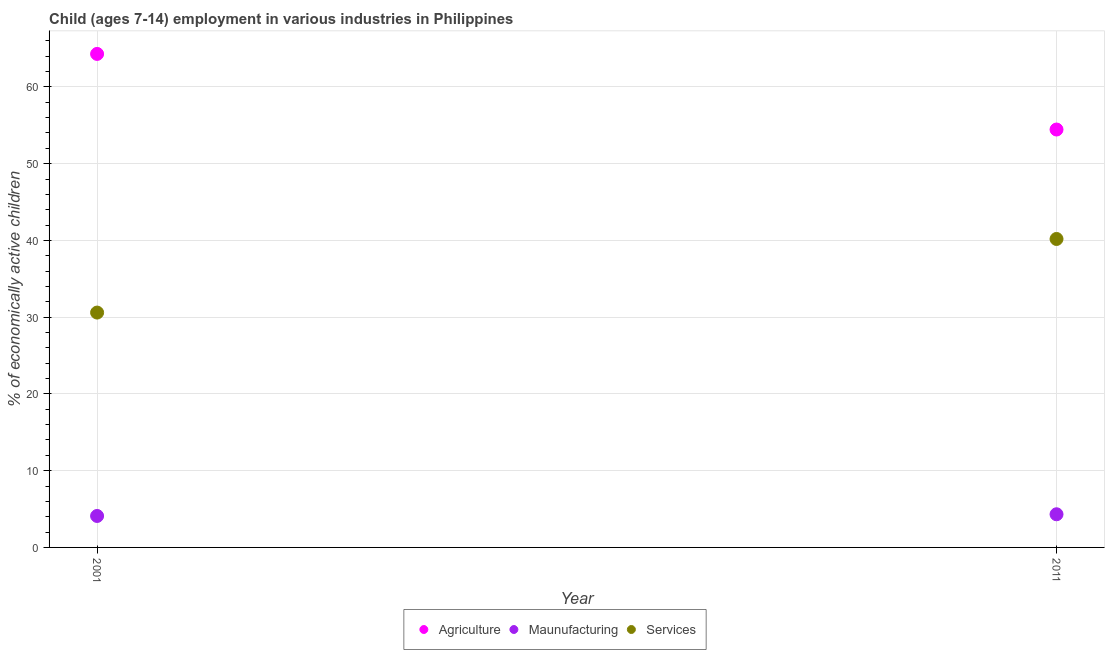How many different coloured dotlines are there?
Your answer should be very brief. 3. Is the number of dotlines equal to the number of legend labels?
Make the answer very short. Yes. What is the percentage of economically active children in manufacturing in 2011?
Offer a very short reply. 4.32. Across all years, what is the maximum percentage of economically active children in services?
Your answer should be compact. 40.19. Across all years, what is the minimum percentage of economically active children in agriculture?
Make the answer very short. 54.45. In which year was the percentage of economically active children in manufacturing maximum?
Give a very brief answer. 2011. What is the total percentage of economically active children in manufacturing in the graph?
Offer a very short reply. 8.42. What is the difference between the percentage of economically active children in agriculture in 2001 and that in 2011?
Give a very brief answer. 9.85. What is the difference between the percentage of economically active children in services in 2011 and the percentage of economically active children in manufacturing in 2001?
Your response must be concise. 36.09. What is the average percentage of economically active children in manufacturing per year?
Keep it short and to the point. 4.21. In the year 2001, what is the difference between the percentage of economically active children in manufacturing and percentage of economically active children in services?
Your answer should be compact. -26.5. What is the ratio of the percentage of economically active children in manufacturing in 2001 to that in 2011?
Your answer should be very brief. 0.95. Is the percentage of economically active children in agriculture in 2001 less than that in 2011?
Ensure brevity in your answer.  No. Is the percentage of economically active children in manufacturing strictly less than the percentage of economically active children in agriculture over the years?
Make the answer very short. Yes. What is the difference between two consecutive major ticks on the Y-axis?
Provide a short and direct response. 10. Does the graph contain grids?
Make the answer very short. Yes. How many legend labels are there?
Your response must be concise. 3. How are the legend labels stacked?
Make the answer very short. Horizontal. What is the title of the graph?
Give a very brief answer. Child (ages 7-14) employment in various industries in Philippines. What is the label or title of the X-axis?
Ensure brevity in your answer.  Year. What is the label or title of the Y-axis?
Ensure brevity in your answer.  % of economically active children. What is the % of economically active children in Agriculture in 2001?
Offer a terse response. 64.3. What is the % of economically active children in Maunufacturing in 2001?
Give a very brief answer. 4.1. What is the % of economically active children of Services in 2001?
Ensure brevity in your answer.  30.6. What is the % of economically active children in Agriculture in 2011?
Offer a very short reply. 54.45. What is the % of economically active children in Maunufacturing in 2011?
Your answer should be compact. 4.32. What is the % of economically active children of Services in 2011?
Your response must be concise. 40.19. Across all years, what is the maximum % of economically active children in Agriculture?
Provide a short and direct response. 64.3. Across all years, what is the maximum % of economically active children of Maunufacturing?
Ensure brevity in your answer.  4.32. Across all years, what is the maximum % of economically active children in Services?
Your answer should be compact. 40.19. Across all years, what is the minimum % of economically active children in Agriculture?
Give a very brief answer. 54.45. Across all years, what is the minimum % of economically active children of Services?
Offer a very short reply. 30.6. What is the total % of economically active children in Agriculture in the graph?
Offer a terse response. 118.75. What is the total % of economically active children of Maunufacturing in the graph?
Make the answer very short. 8.42. What is the total % of economically active children in Services in the graph?
Provide a short and direct response. 70.79. What is the difference between the % of economically active children in Agriculture in 2001 and that in 2011?
Ensure brevity in your answer.  9.85. What is the difference between the % of economically active children of Maunufacturing in 2001 and that in 2011?
Make the answer very short. -0.22. What is the difference between the % of economically active children of Services in 2001 and that in 2011?
Offer a terse response. -9.59. What is the difference between the % of economically active children of Agriculture in 2001 and the % of economically active children of Maunufacturing in 2011?
Your answer should be compact. 59.98. What is the difference between the % of economically active children in Agriculture in 2001 and the % of economically active children in Services in 2011?
Ensure brevity in your answer.  24.11. What is the difference between the % of economically active children in Maunufacturing in 2001 and the % of economically active children in Services in 2011?
Make the answer very short. -36.09. What is the average % of economically active children in Agriculture per year?
Offer a very short reply. 59.38. What is the average % of economically active children in Maunufacturing per year?
Provide a short and direct response. 4.21. What is the average % of economically active children in Services per year?
Offer a very short reply. 35.4. In the year 2001, what is the difference between the % of economically active children in Agriculture and % of economically active children in Maunufacturing?
Offer a terse response. 60.2. In the year 2001, what is the difference between the % of economically active children in Agriculture and % of economically active children in Services?
Your answer should be very brief. 33.7. In the year 2001, what is the difference between the % of economically active children in Maunufacturing and % of economically active children in Services?
Offer a very short reply. -26.5. In the year 2011, what is the difference between the % of economically active children of Agriculture and % of economically active children of Maunufacturing?
Offer a terse response. 50.13. In the year 2011, what is the difference between the % of economically active children in Agriculture and % of economically active children in Services?
Offer a terse response. 14.26. In the year 2011, what is the difference between the % of economically active children in Maunufacturing and % of economically active children in Services?
Your answer should be very brief. -35.87. What is the ratio of the % of economically active children of Agriculture in 2001 to that in 2011?
Keep it short and to the point. 1.18. What is the ratio of the % of economically active children of Maunufacturing in 2001 to that in 2011?
Offer a very short reply. 0.95. What is the ratio of the % of economically active children in Services in 2001 to that in 2011?
Your answer should be very brief. 0.76. What is the difference between the highest and the second highest % of economically active children of Agriculture?
Give a very brief answer. 9.85. What is the difference between the highest and the second highest % of economically active children in Maunufacturing?
Provide a short and direct response. 0.22. What is the difference between the highest and the second highest % of economically active children in Services?
Offer a very short reply. 9.59. What is the difference between the highest and the lowest % of economically active children of Agriculture?
Provide a succinct answer. 9.85. What is the difference between the highest and the lowest % of economically active children in Maunufacturing?
Provide a succinct answer. 0.22. What is the difference between the highest and the lowest % of economically active children of Services?
Offer a terse response. 9.59. 